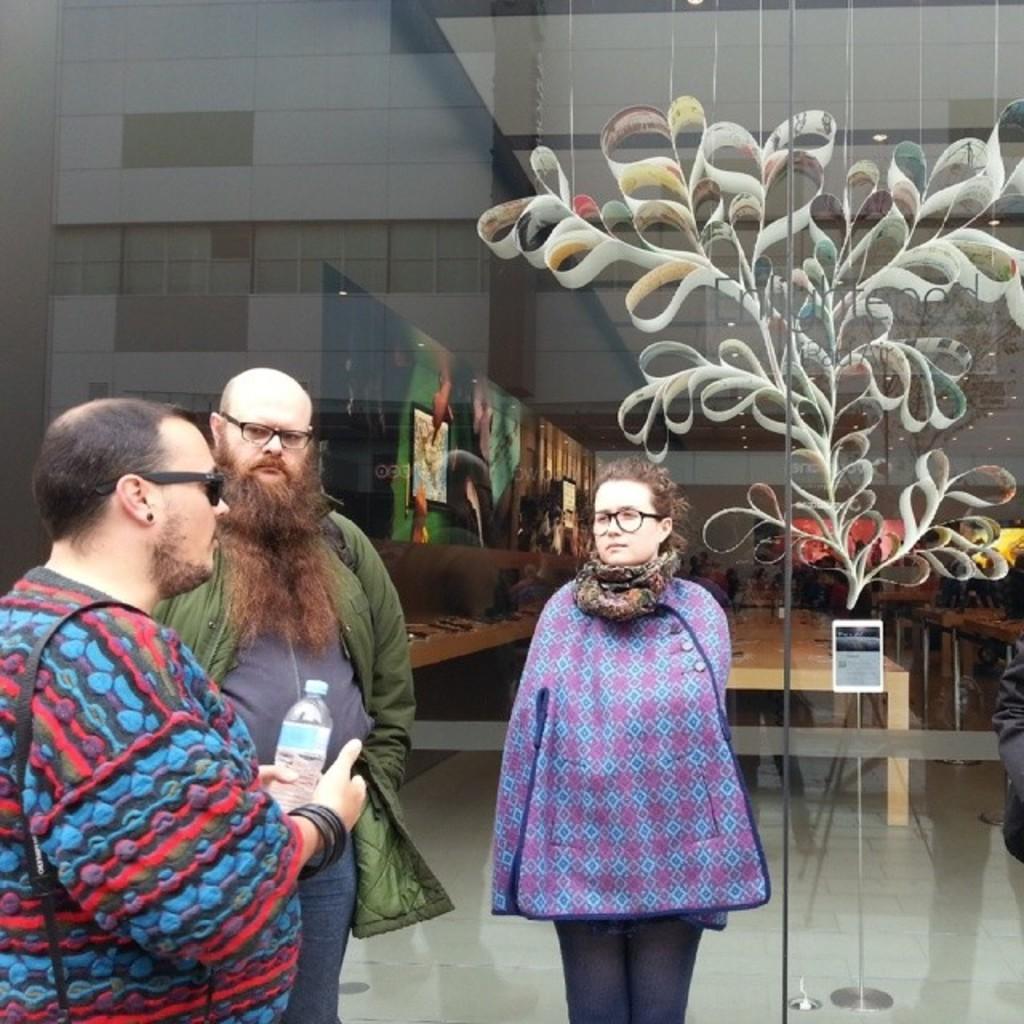Can you describe this image briefly? In this image we can see people standing on the floor and one of them is holding disposal bottle in the hands. In the background there are display screens and paintings to the walls, persons standing on the floor and electric lights. 